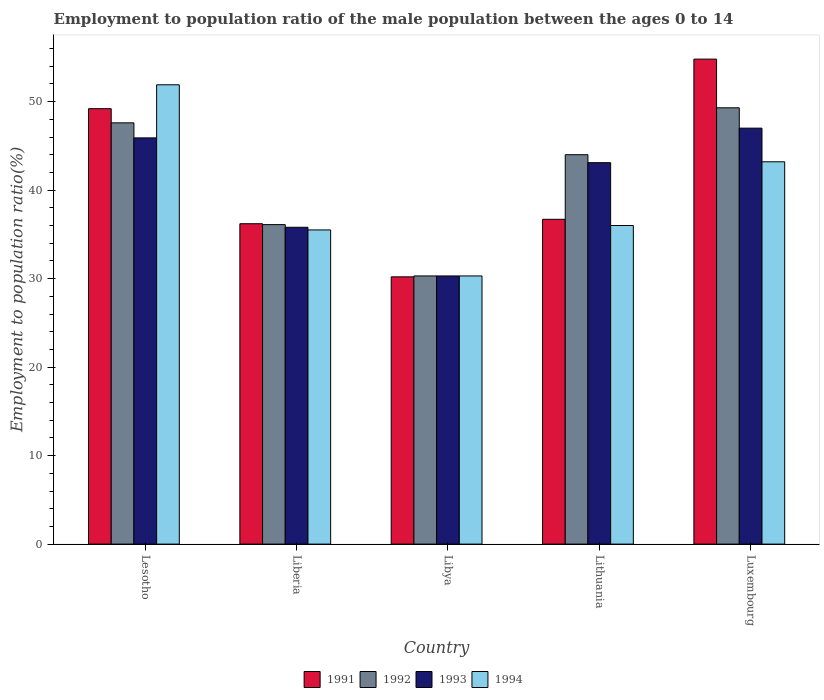How many groups of bars are there?
Provide a succinct answer. 5. How many bars are there on the 4th tick from the left?
Provide a short and direct response. 4. How many bars are there on the 4th tick from the right?
Keep it short and to the point. 4. What is the label of the 1st group of bars from the left?
Offer a very short reply. Lesotho. In how many cases, is the number of bars for a given country not equal to the number of legend labels?
Ensure brevity in your answer.  0. What is the employment to population ratio in 1994 in Libya?
Offer a terse response. 30.3. Across all countries, what is the minimum employment to population ratio in 1993?
Provide a short and direct response. 30.3. In which country was the employment to population ratio in 1991 maximum?
Offer a very short reply. Luxembourg. In which country was the employment to population ratio in 1993 minimum?
Offer a terse response. Libya. What is the total employment to population ratio in 1991 in the graph?
Make the answer very short. 207.1. What is the difference between the employment to population ratio in 1992 in Lesotho and that in Libya?
Offer a terse response. 17.3. What is the difference between the employment to population ratio in 1991 in Libya and the employment to population ratio in 1992 in Lithuania?
Your response must be concise. -13.8. What is the average employment to population ratio in 1991 per country?
Your answer should be very brief. 41.42. What is the difference between the employment to population ratio of/in 1993 and employment to population ratio of/in 1994 in Lithuania?
Your answer should be very brief. 7.1. In how many countries, is the employment to population ratio in 1993 greater than 20 %?
Provide a short and direct response. 5. What is the ratio of the employment to population ratio in 1991 in Lesotho to that in Luxembourg?
Give a very brief answer. 0.9. Is the employment to population ratio in 1994 in Libya less than that in Luxembourg?
Offer a terse response. Yes. Is the difference between the employment to population ratio in 1993 in Liberia and Luxembourg greater than the difference between the employment to population ratio in 1994 in Liberia and Luxembourg?
Give a very brief answer. No. What is the difference between the highest and the second highest employment to population ratio in 1992?
Make the answer very short. 5.3. What is the difference between the highest and the lowest employment to population ratio in 1994?
Provide a short and direct response. 21.6. In how many countries, is the employment to population ratio in 1994 greater than the average employment to population ratio in 1994 taken over all countries?
Provide a succinct answer. 2. What does the 1st bar from the left in Lithuania represents?
Provide a succinct answer. 1991. Are all the bars in the graph horizontal?
Ensure brevity in your answer.  No. How many countries are there in the graph?
Your answer should be compact. 5. What is the difference between two consecutive major ticks on the Y-axis?
Offer a terse response. 10. Where does the legend appear in the graph?
Your response must be concise. Bottom center. How many legend labels are there?
Your answer should be very brief. 4. How are the legend labels stacked?
Offer a terse response. Horizontal. What is the title of the graph?
Your answer should be compact. Employment to population ratio of the male population between the ages 0 to 14. Does "2009" appear as one of the legend labels in the graph?
Your response must be concise. No. What is the label or title of the X-axis?
Provide a short and direct response. Country. What is the Employment to population ratio(%) of 1991 in Lesotho?
Offer a very short reply. 49.2. What is the Employment to population ratio(%) in 1992 in Lesotho?
Provide a succinct answer. 47.6. What is the Employment to population ratio(%) in 1993 in Lesotho?
Your response must be concise. 45.9. What is the Employment to population ratio(%) of 1994 in Lesotho?
Provide a short and direct response. 51.9. What is the Employment to population ratio(%) in 1991 in Liberia?
Your response must be concise. 36.2. What is the Employment to population ratio(%) in 1992 in Liberia?
Offer a very short reply. 36.1. What is the Employment to population ratio(%) of 1993 in Liberia?
Your answer should be compact. 35.8. What is the Employment to population ratio(%) in 1994 in Liberia?
Your response must be concise. 35.5. What is the Employment to population ratio(%) in 1991 in Libya?
Your response must be concise. 30.2. What is the Employment to population ratio(%) in 1992 in Libya?
Provide a succinct answer. 30.3. What is the Employment to population ratio(%) in 1993 in Libya?
Keep it short and to the point. 30.3. What is the Employment to population ratio(%) in 1994 in Libya?
Your response must be concise. 30.3. What is the Employment to population ratio(%) in 1991 in Lithuania?
Offer a very short reply. 36.7. What is the Employment to population ratio(%) in 1993 in Lithuania?
Your answer should be compact. 43.1. What is the Employment to population ratio(%) of 1994 in Lithuania?
Your answer should be very brief. 36. What is the Employment to population ratio(%) in 1991 in Luxembourg?
Provide a succinct answer. 54.8. What is the Employment to population ratio(%) in 1992 in Luxembourg?
Offer a terse response. 49.3. What is the Employment to population ratio(%) in 1994 in Luxembourg?
Keep it short and to the point. 43.2. Across all countries, what is the maximum Employment to population ratio(%) in 1991?
Keep it short and to the point. 54.8. Across all countries, what is the maximum Employment to population ratio(%) in 1992?
Provide a succinct answer. 49.3. Across all countries, what is the maximum Employment to population ratio(%) in 1994?
Offer a terse response. 51.9. Across all countries, what is the minimum Employment to population ratio(%) of 1991?
Give a very brief answer. 30.2. Across all countries, what is the minimum Employment to population ratio(%) of 1992?
Your answer should be very brief. 30.3. Across all countries, what is the minimum Employment to population ratio(%) of 1993?
Offer a very short reply. 30.3. Across all countries, what is the minimum Employment to population ratio(%) in 1994?
Give a very brief answer. 30.3. What is the total Employment to population ratio(%) in 1991 in the graph?
Your response must be concise. 207.1. What is the total Employment to population ratio(%) in 1992 in the graph?
Provide a succinct answer. 207.3. What is the total Employment to population ratio(%) of 1993 in the graph?
Your response must be concise. 202.1. What is the total Employment to population ratio(%) of 1994 in the graph?
Offer a very short reply. 196.9. What is the difference between the Employment to population ratio(%) of 1993 in Lesotho and that in Liberia?
Keep it short and to the point. 10.1. What is the difference between the Employment to population ratio(%) of 1991 in Lesotho and that in Libya?
Your answer should be very brief. 19. What is the difference between the Employment to population ratio(%) of 1994 in Lesotho and that in Libya?
Provide a succinct answer. 21.6. What is the difference between the Employment to population ratio(%) of 1991 in Lesotho and that in Lithuania?
Make the answer very short. 12.5. What is the difference between the Employment to population ratio(%) of 1993 in Lesotho and that in Lithuania?
Provide a succinct answer. 2.8. What is the difference between the Employment to population ratio(%) in 1991 in Lesotho and that in Luxembourg?
Keep it short and to the point. -5.6. What is the difference between the Employment to population ratio(%) in 1993 in Lesotho and that in Luxembourg?
Provide a short and direct response. -1.1. What is the difference between the Employment to population ratio(%) of 1991 in Liberia and that in Libya?
Offer a very short reply. 6. What is the difference between the Employment to population ratio(%) in 1993 in Liberia and that in Lithuania?
Provide a succinct answer. -7.3. What is the difference between the Employment to population ratio(%) in 1991 in Liberia and that in Luxembourg?
Your answer should be compact. -18.6. What is the difference between the Employment to population ratio(%) of 1993 in Liberia and that in Luxembourg?
Offer a very short reply. -11.2. What is the difference between the Employment to population ratio(%) in 1994 in Liberia and that in Luxembourg?
Provide a succinct answer. -7.7. What is the difference between the Employment to population ratio(%) in 1992 in Libya and that in Lithuania?
Make the answer very short. -13.7. What is the difference between the Employment to population ratio(%) of 1994 in Libya and that in Lithuania?
Offer a terse response. -5.7. What is the difference between the Employment to population ratio(%) in 1991 in Libya and that in Luxembourg?
Keep it short and to the point. -24.6. What is the difference between the Employment to population ratio(%) of 1992 in Libya and that in Luxembourg?
Your answer should be very brief. -19. What is the difference between the Employment to population ratio(%) of 1993 in Libya and that in Luxembourg?
Offer a very short reply. -16.7. What is the difference between the Employment to population ratio(%) in 1991 in Lithuania and that in Luxembourg?
Make the answer very short. -18.1. What is the difference between the Employment to population ratio(%) of 1991 in Lesotho and the Employment to population ratio(%) of 1994 in Liberia?
Keep it short and to the point. 13.7. What is the difference between the Employment to population ratio(%) of 1992 in Lesotho and the Employment to population ratio(%) of 1993 in Liberia?
Make the answer very short. 11.8. What is the difference between the Employment to population ratio(%) of 1993 in Lesotho and the Employment to population ratio(%) of 1994 in Liberia?
Provide a short and direct response. 10.4. What is the difference between the Employment to population ratio(%) of 1991 in Lesotho and the Employment to population ratio(%) of 1993 in Libya?
Offer a terse response. 18.9. What is the difference between the Employment to population ratio(%) in 1991 in Lesotho and the Employment to population ratio(%) in 1994 in Libya?
Your response must be concise. 18.9. What is the difference between the Employment to population ratio(%) of 1992 in Lesotho and the Employment to population ratio(%) of 1993 in Libya?
Your answer should be compact. 17.3. What is the difference between the Employment to population ratio(%) in 1993 in Lesotho and the Employment to population ratio(%) in 1994 in Libya?
Your response must be concise. 15.6. What is the difference between the Employment to population ratio(%) in 1991 in Lesotho and the Employment to population ratio(%) in 1993 in Lithuania?
Ensure brevity in your answer.  6.1. What is the difference between the Employment to population ratio(%) of 1991 in Lesotho and the Employment to population ratio(%) of 1994 in Lithuania?
Give a very brief answer. 13.2. What is the difference between the Employment to population ratio(%) of 1992 in Lesotho and the Employment to population ratio(%) of 1994 in Lithuania?
Your answer should be compact. 11.6. What is the difference between the Employment to population ratio(%) of 1992 in Lesotho and the Employment to population ratio(%) of 1993 in Luxembourg?
Give a very brief answer. 0.6. What is the difference between the Employment to population ratio(%) of 1992 in Lesotho and the Employment to population ratio(%) of 1994 in Luxembourg?
Your answer should be compact. 4.4. What is the difference between the Employment to population ratio(%) of 1993 in Lesotho and the Employment to population ratio(%) of 1994 in Luxembourg?
Keep it short and to the point. 2.7. What is the difference between the Employment to population ratio(%) in 1991 in Liberia and the Employment to population ratio(%) in 1993 in Libya?
Your response must be concise. 5.9. What is the difference between the Employment to population ratio(%) of 1991 in Liberia and the Employment to population ratio(%) of 1994 in Libya?
Your answer should be very brief. 5.9. What is the difference between the Employment to population ratio(%) of 1992 in Liberia and the Employment to population ratio(%) of 1993 in Libya?
Your response must be concise. 5.8. What is the difference between the Employment to population ratio(%) of 1991 in Liberia and the Employment to population ratio(%) of 1992 in Lithuania?
Your answer should be very brief. -7.8. What is the difference between the Employment to population ratio(%) of 1991 in Liberia and the Employment to population ratio(%) of 1993 in Lithuania?
Your answer should be compact. -6.9. What is the difference between the Employment to population ratio(%) of 1992 in Liberia and the Employment to population ratio(%) of 1994 in Lithuania?
Offer a very short reply. 0.1. What is the difference between the Employment to population ratio(%) of 1992 in Liberia and the Employment to population ratio(%) of 1993 in Luxembourg?
Provide a short and direct response. -10.9. What is the difference between the Employment to population ratio(%) in 1992 in Liberia and the Employment to population ratio(%) in 1994 in Luxembourg?
Your answer should be compact. -7.1. What is the difference between the Employment to population ratio(%) of 1991 in Libya and the Employment to population ratio(%) of 1992 in Lithuania?
Give a very brief answer. -13.8. What is the difference between the Employment to population ratio(%) in 1991 in Libya and the Employment to population ratio(%) in 1993 in Lithuania?
Make the answer very short. -12.9. What is the difference between the Employment to population ratio(%) in 1991 in Libya and the Employment to population ratio(%) in 1994 in Lithuania?
Offer a very short reply. -5.8. What is the difference between the Employment to population ratio(%) in 1992 in Libya and the Employment to population ratio(%) in 1993 in Lithuania?
Offer a very short reply. -12.8. What is the difference between the Employment to population ratio(%) in 1992 in Libya and the Employment to population ratio(%) in 1994 in Lithuania?
Offer a terse response. -5.7. What is the difference between the Employment to population ratio(%) of 1993 in Libya and the Employment to population ratio(%) of 1994 in Lithuania?
Provide a succinct answer. -5.7. What is the difference between the Employment to population ratio(%) in 1991 in Libya and the Employment to population ratio(%) in 1992 in Luxembourg?
Offer a very short reply. -19.1. What is the difference between the Employment to population ratio(%) of 1991 in Libya and the Employment to population ratio(%) of 1993 in Luxembourg?
Your answer should be very brief. -16.8. What is the difference between the Employment to population ratio(%) of 1992 in Libya and the Employment to population ratio(%) of 1993 in Luxembourg?
Make the answer very short. -16.7. What is the difference between the Employment to population ratio(%) of 1993 in Libya and the Employment to population ratio(%) of 1994 in Luxembourg?
Provide a short and direct response. -12.9. What is the difference between the Employment to population ratio(%) of 1991 in Lithuania and the Employment to population ratio(%) of 1992 in Luxembourg?
Ensure brevity in your answer.  -12.6. What is the difference between the Employment to population ratio(%) in 1992 in Lithuania and the Employment to population ratio(%) in 1993 in Luxembourg?
Make the answer very short. -3. What is the difference between the Employment to population ratio(%) of 1993 in Lithuania and the Employment to population ratio(%) of 1994 in Luxembourg?
Your answer should be very brief. -0.1. What is the average Employment to population ratio(%) in 1991 per country?
Your response must be concise. 41.42. What is the average Employment to population ratio(%) of 1992 per country?
Your answer should be very brief. 41.46. What is the average Employment to population ratio(%) in 1993 per country?
Provide a succinct answer. 40.42. What is the average Employment to population ratio(%) of 1994 per country?
Your answer should be compact. 39.38. What is the difference between the Employment to population ratio(%) in 1991 and Employment to population ratio(%) in 1993 in Lesotho?
Your answer should be very brief. 3.3. What is the difference between the Employment to population ratio(%) of 1991 and Employment to population ratio(%) of 1994 in Lesotho?
Give a very brief answer. -2.7. What is the difference between the Employment to population ratio(%) of 1992 and Employment to population ratio(%) of 1993 in Lesotho?
Provide a short and direct response. 1.7. What is the difference between the Employment to population ratio(%) of 1993 and Employment to population ratio(%) of 1994 in Lesotho?
Offer a very short reply. -6. What is the difference between the Employment to population ratio(%) of 1992 and Employment to population ratio(%) of 1994 in Liberia?
Your answer should be very brief. 0.6. What is the difference between the Employment to population ratio(%) in 1991 and Employment to population ratio(%) in 1992 in Libya?
Your answer should be very brief. -0.1. What is the difference between the Employment to population ratio(%) of 1991 and Employment to population ratio(%) of 1993 in Libya?
Give a very brief answer. -0.1. What is the difference between the Employment to population ratio(%) in 1991 and Employment to population ratio(%) in 1994 in Libya?
Ensure brevity in your answer.  -0.1. What is the difference between the Employment to population ratio(%) of 1993 and Employment to population ratio(%) of 1994 in Libya?
Your response must be concise. 0. What is the difference between the Employment to population ratio(%) of 1991 and Employment to population ratio(%) of 1992 in Lithuania?
Keep it short and to the point. -7.3. What is the difference between the Employment to population ratio(%) of 1992 and Employment to population ratio(%) of 1994 in Lithuania?
Your answer should be very brief. 8. What is the difference between the Employment to population ratio(%) of 1993 and Employment to population ratio(%) of 1994 in Luxembourg?
Provide a succinct answer. 3.8. What is the ratio of the Employment to population ratio(%) of 1991 in Lesotho to that in Liberia?
Provide a succinct answer. 1.36. What is the ratio of the Employment to population ratio(%) of 1992 in Lesotho to that in Liberia?
Your answer should be very brief. 1.32. What is the ratio of the Employment to population ratio(%) in 1993 in Lesotho to that in Liberia?
Your answer should be very brief. 1.28. What is the ratio of the Employment to population ratio(%) of 1994 in Lesotho to that in Liberia?
Give a very brief answer. 1.46. What is the ratio of the Employment to population ratio(%) in 1991 in Lesotho to that in Libya?
Offer a terse response. 1.63. What is the ratio of the Employment to population ratio(%) in 1992 in Lesotho to that in Libya?
Your answer should be very brief. 1.57. What is the ratio of the Employment to population ratio(%) in 1993 in Lesotho to that in Libya?
Provide a succinct answer. 1.51. What is the ratio of the Employment to population ratio(%) of 1994 in Lesotho to that in Libya?
Offer a very short reply. 1.71. What is the ratio of the Employment to population ratio(%) in 1991 in Lesotho to that in Lithuania?
Offer a terse response. 1.34. What is the ratio of the Employment to population ratio(%) of 1992 in Lesotho to that in Lithuania?
Your answer should be compact. 1.08. What is the ratio of the Employment to population ratio(%) in 1993 in Lesotho to that in Lithuania?
Your answer should be compact. 1.06. What is the ratio of the Employment to population ratio(%) of 1994 in Lesotho to that in Lithuania?
Your answer should be very brief. 1.44. What is the ratio of the Employment to population ratio(%) of 1991 in Lesotho to that in Luxembourg?
Make the answer very short. 0.9. What is the ratio of the Employment to population ratio(%) of 1992 in Lesotho to that in Luxembourg?
Your answer should be very brief. 0.97. What is the ratio of the Employment to population ratio(%) of 1993 in Lesotho to that in Luxembourg?
Your answer should be compact. 0.98. What is the ratio of the Employment to population ratio(%) in 1994 in Lesotho to that in Luxembourg?
Your answer should be very brief. 1.2. What is the ratio of the Employment to population ratio(%) in 1991 in Liberia to that in Libya?
Your answer should be compact. 1.2. What is the ratio of the Employment to population ratio(%) of 1992 in Liberia to that in Libya?
Provide a succinct answer. 1.19. What is the ratio of the Employment to population ratio(%) in 1993 in Liberia to that in Libya?
Give a very brief answer. 1.18. What is the ratio of the Employment to population ratio(%) of 1994 in Liberia to that in Libya?
Ensure brevity in your answer.  1.17. What is the ratio of the Employment to population ratio(%) in 1991 in Liberia to that in Lithuania?
Keep it short and to the point. 0.99. What is the ratio of the Employment to population ratio(%) in 1992 in Liberia to that in Lithuania?
Give a very brief answer. 0.82. What is the ratio of the Employment to population ratio(%) of 1993 in Liberia to that in Lithuania?
Your answer should be very brief. 0.83. What is the ratio of the Employment to population ratio(%) of 1994 in Liberia to that in Lithuania?
Keep it short and to the point. 0.99. What is the ratio of the Employment to population ratio(%) of 1991 in Liberia to that in Luxembourg?
Give a very brief answer. 0.66. What is the ratio of the Employment to population ratio(%) of 1992 in Liberia to that in Luxembourg?
Ensure brevity in your answer.  0.73. What is the ratio of the Employment to population ratio(%) of 1993 in Liberia to that in Luxembourg?
Your answer should be very brief. 0.76. What is the ratio of the Employment to population ratio(%) in 1994 in Liberia to that in Luxembourg?
Offer a very short reply. 0.82. What is the ratio of the Employment to population ratio(%) in 1991 in Libya to that in Lithuania?
Make the answer very short. 0.82. What is the ratio of the Employment to population ratio(%) of 1992 in Libya to that in Lithuania?
Your response must be concise. 0.69. What is the ratio of the Employment to population ratio(%) of 1993 in Libya to that in Lithuania?
Make the answer very short. 0.7. What is the ratio of the Employment to population ratio(%) in 1994 in Libya to that in Lithuania?
Make the answer very short. 0.84. What is the ratio of the Employment to population ratio(%) in 1991 in Libya to that in Luxembourg?
Your response must be concise. 0.55. What is the ratio of the Employment to population ratio(%) of 1992 in Libya to that in Luxembourg?
Provide a short and direct response. 0.61. What is the ratio of the Employment to population ratio(%) of 1993 in Libya to that in Luxembourg?
Offer a very short reply. 0.64. What is the ratio of the Employment to population ratio(%) in 1994 in Libya to that in Luxembourg?
Offer a terse response. 0.7. What is the ratio of the Employment to population ratio(%) of 1991 in Lithuania to that in Luxembourg?
Make the answer very short. 0.67. What is the ratio of the Employment to population ratio(%) of 1992 in Lithuania to that in Luxembourg?
Keep it short and to the point. 0.89. What is the ratio of the Employment to population ratio(%) in 1993 in Lithuania to that in Luxembourg?
Provide a succinct answer. 0.92. What is the difference between the highest and the second highest Employment to population ratio(%) in 1992?
Offer a terse response. 1.7. What is the difference between the highest and the second highest Employment to population ratio(%) in 1993?
Provide a succinct answer. 1.1. What is the difference between the highest and the second highest Employment to population ratio(%) in 1994?
Give a very brief answer. 8.7. What is the difference between the highest and the lowest Employment to population ratio(%) in 1991?
Offer a very short reply. 24.6. What is the difference between the highest and the lowest Employment to population ratio(%) in 1992?
Ensure brevity in your answer.  19. What is the difference between the highest and the lowest Employment to population ratio(%) of 1993?
Your response must be concise. 16.7. What is the difference between the highest and the lowest Employment to population ratio(%) of 1994?
Ensure brevity in your answer.  21.6. 